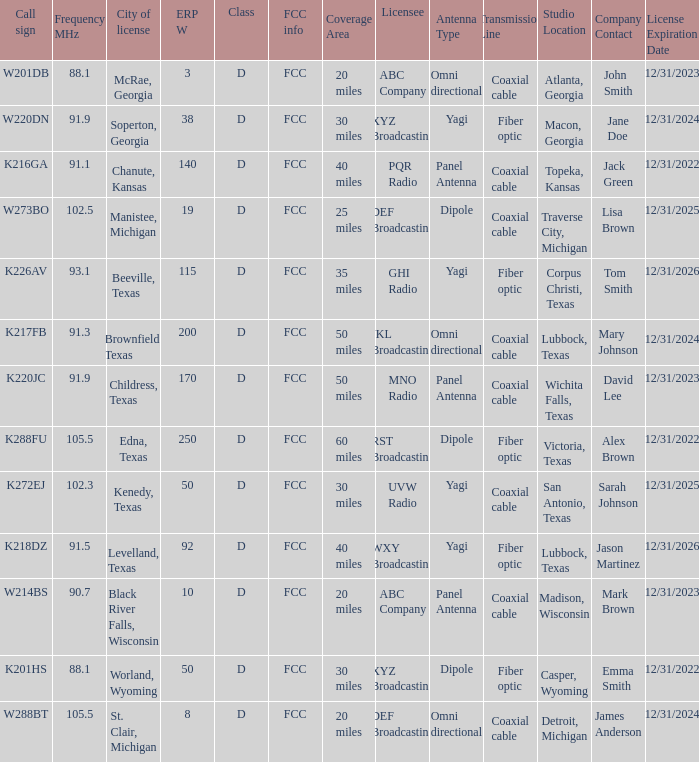What is Call Sign, when City of License is Brownfield, Texas? K217FB. 